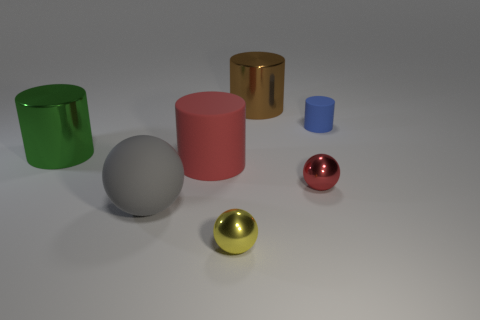What size is the cylinder on the left side of the big thing in front of the red metal sphere?
Offer a very short reply. Large. There is a red object that is to the left of the large brown metallic cylinder; what is it made of?
Provide a succinct answer. Rubber. There is a red cylinder that is the same material as the gray thing; what is its size?
Offer a very short reply. Large. How many big gray matte things are the same shape as the tiny red object?
Provide a succinct answer. 1. Does the yellow thing have the same shape as the tiny metallic thing behind the big rubber sphere?
Provide a short and direct response. Yes. There is a shiny thing that is the same color as the big rubber cylinder; what is its shape?
Your answer should be compact. Sphere. Are there any small things that have the same material as the tiny blue cylinder?
Your answer should be compact. No. The cylinder in front of the big metallic thing that is to the left of the brown cylinder is made of what material?
Your answer should be very brief. Rubber. What size is the red object to the left of the large metal cylinder that is on the right side of the big object on the left side of the large gray ball?
Your answer should be compact. Large. How many other things are there of the same shape as the small yellow shiny object?
Your answer should be very brief. 2. 